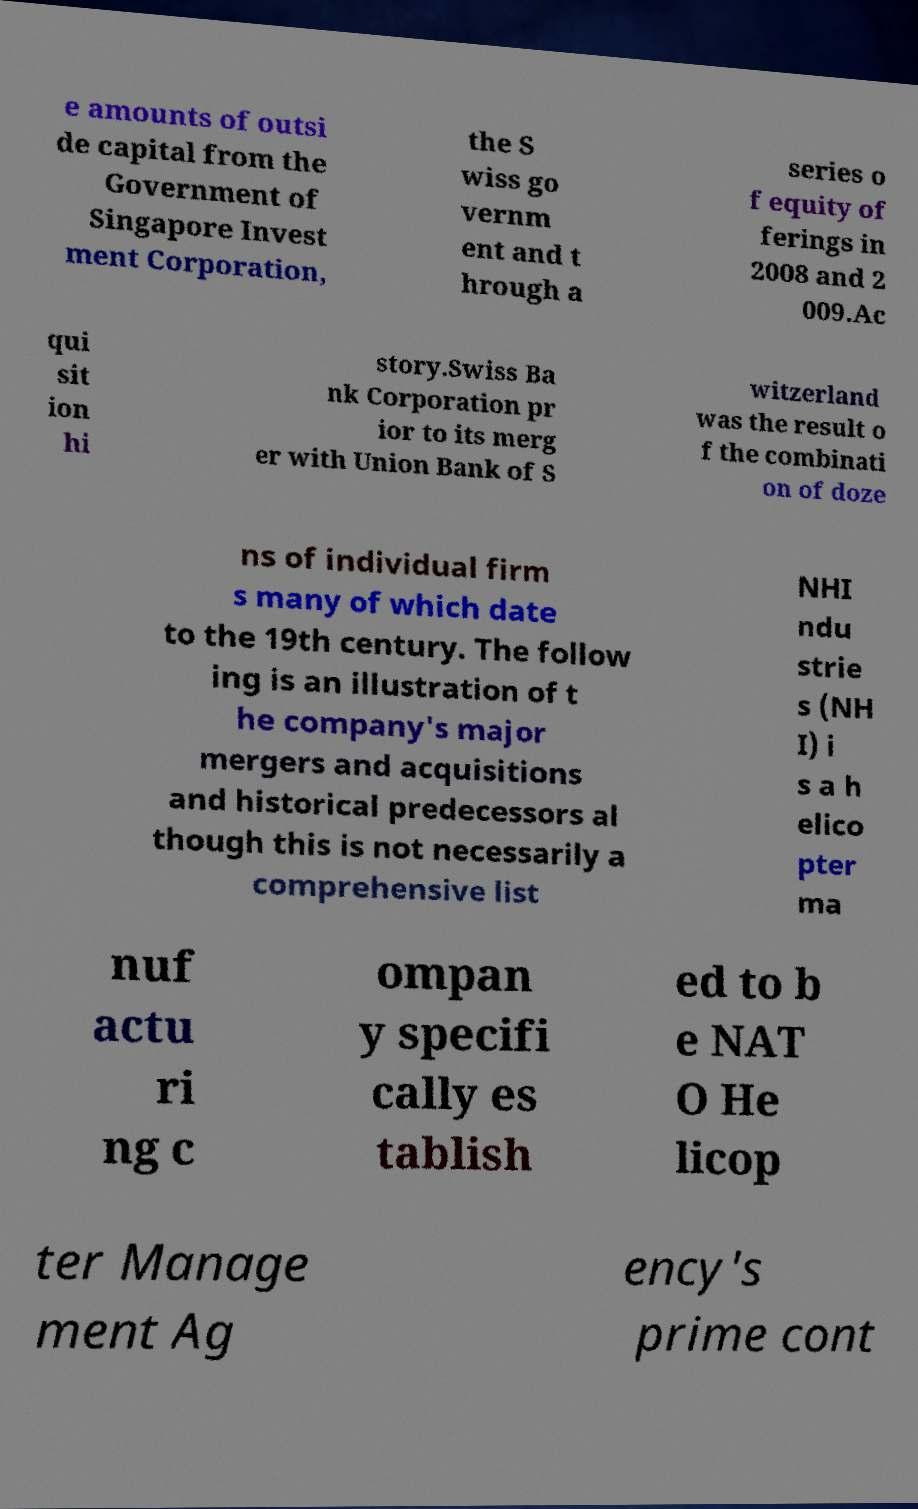Could you assist in decoding the text presented in this image and type it out clearly? e amounts of outsi de capital from the Government of Singapore Invest ment Corporation, the S wiss go vernm ent and t hrough a series o f equity of ferings in 2008 and 2 009.Ac qui sit ion hi story.Swiss Ba nk Corporation pr ior to its merg er with Union Bank of S witzerland was the result o f the combinati on of doze ns of individual firm s many of which date to the 19th century. The follow ing is an illustration of t he company's major mergers and acquisitions and historical predecessors al though this is not necessarily a comprehensive list NHI ndu strie s (NH I) i s a h elico pter ma nuf actu ri ng c ompan y specifi cally es tablish ed to b e NAT O He licop ter Manage ment Ag ency's prime cont 